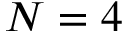Convert formula to latex. <formula><loc_0><loc_0><loc_500><loc_500>N = 4</formula> 